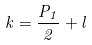Convert formula to latex. <formula><loc_0><loc_0><loc_500><loc_500>k = \frac { P _ { 1 } } { 2 } + l</formula> 